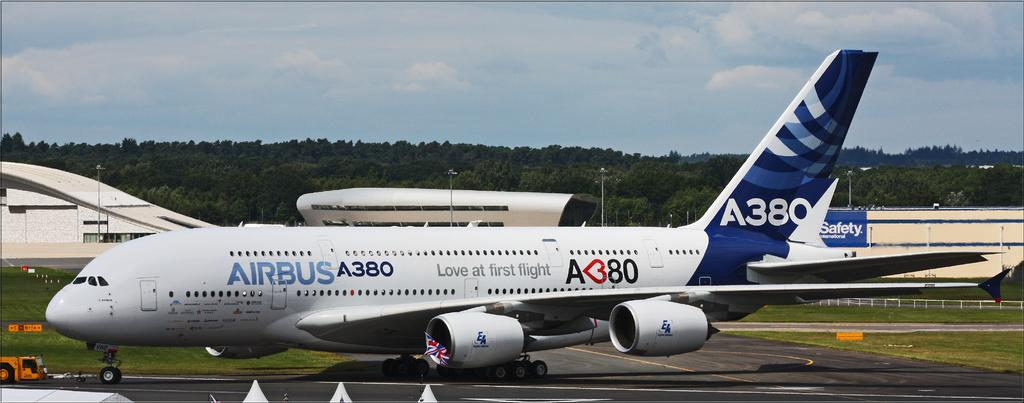What type of transportation is depicted in the image? There is a flight in the image. What else can be seen on the ground in the image? There is a road, objects, buildings, and trees visible on the ground in the image. What is the condition of the sky in the image? The sky is visible in the image, and there are clouds present. How many bricks are used to build the fifth building in the image? There is no information about the number of bricks or the specific buildings in the image, so this question cannot be answered definitively. 